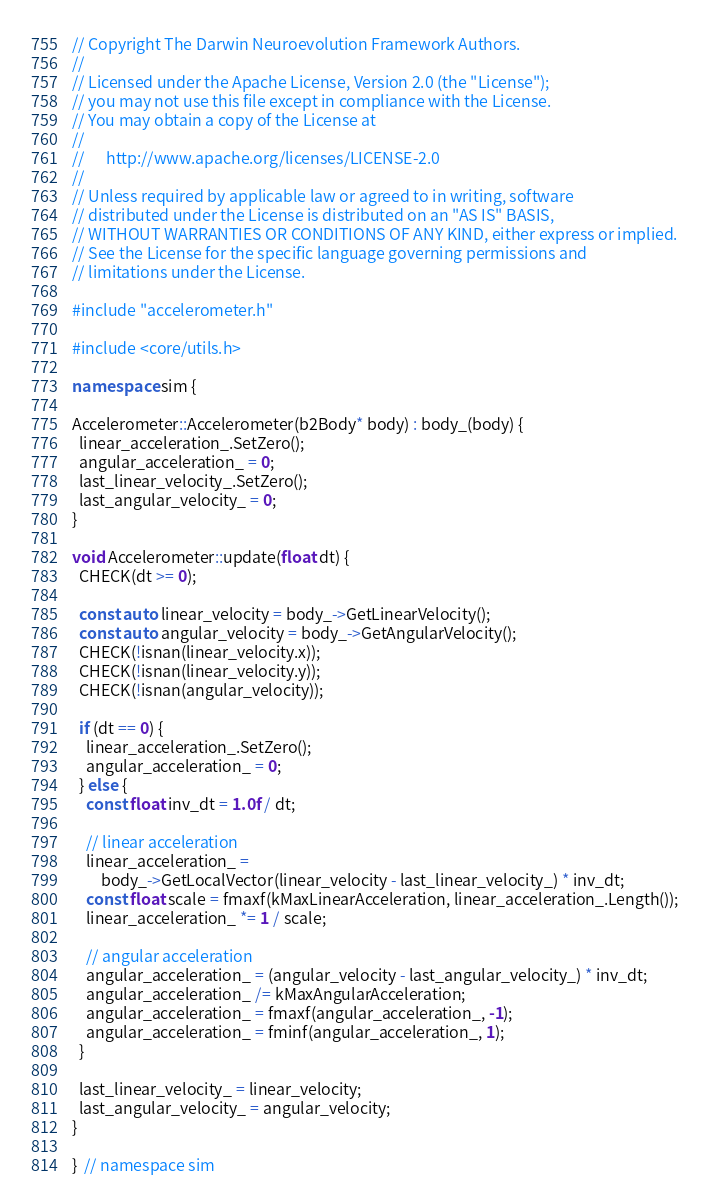Convert code to text. <code><loc_0><loc_0><loc_500><loc_500><_C++_>// Copyright The Darwin Neuroevolution Framework Authors.
//
// Licensed under the Apache License, Version 2.0 (the "License");
// you may not use this file except in compliance with the License.
// You may obtain a copy of the License at
//
//      http://www.apache.org/licenses/LICENSE-2.0
//
// Unless required by applicable law or agreed to in writing, software
// distributed under the License is distributed on an "AS IS" BASIS,
// WITHOUT WARRANTIES OR CONDITIONS OF ANY KIND, either express or implied.
// See the License for the specific language governing permissions and
// limitations under the License.

#include "accelerometer.h"

#include <core/utils.h>

namespace sim {

Accelerometer::Accelerometer(b2Body* body) : body_(body) {
  linear_acceleration_.SetZero();
  angular_acceleration_ = 0;
  last_linear_velocity_.SetZero();
  last_angular_velocity_ = 0;
}

void Accelerometer::update(float dt) {
  CHECK(dt >= 0);

  const auto linear_velocity = body_->GetLinearVelocity();
  const auto angular_velocity = body_->GetAngularVelocity();
  CHECK(!isnan(linear_velocity.x));
  CHECK(!isnan(linear_velocity.y));
  CHECK(!isnan(angular_velocity));

  if (dt == 0) {
    linear_acceleration_.SetZero();
    angular_acceleration_ = 0;
  } else {
    const float inv_dt = 1.0f / dt;

    // linear acceleration
    linear_acceleration_ =
        body_->GetLocalVector(linear_velocity - last_linear_velocity_) * inv_dt;
    const float scale = fmaxf(kMaxLinearAcceleration, linear_acceleration_.Length());
    linear_acceleration_ *= 1 / scale;

    // angular acceleration
    angular_acceleration_ = (angular_velocity - last_angular_velocity_) * inv_dt;
    angular_acceleration_ /= kMaxAngularAcceleration;
    angular_acceleration_ = fmaxf(angular_acceleration_, -1);
    angular_acceleration_ = fminf(angular_acceleration_, 1);
  }

  last_linear_velocity_ = linear_velocity;
  last_angular_velocity_ = angular_velocity;
}

}  // namespace sim
</code> 